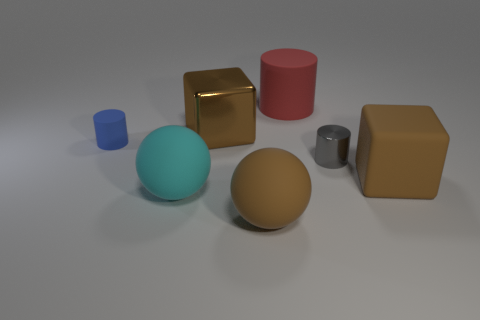What number of other things have the same material as the blue thing?
Your answer should be very brief. 4. There is a big metallic object; is its color the same as the matte thing that is to the right of the tiny gray metallic cylinder?
Give a very brief answer. Yes. What is the color of the tiny cylinder on the left side of the large brown matte thing that is left of the red cylinder?
Your response must be concise. Blue. There is a metal block that is the same size as the red rubber cylinder; what is its color?
Provide a succinct answer. Brown. Is there another cyan rubber thing that has the same shape as the large cyan object?
Ensure brevity in your answer.  No. What shape is the tiny gray shiny thing?
Make the answer very short. Cylinder. Are there more small blue cylinders to the right of the large cyan sphere than brown matte blocks left of the small blue object?
Provide a succinct answer. No. How many other things are there of the same size as the cyan ball?
Provide a short and direct response. 4. The large brown object that is both to the left of the small gray object and behind the big cyan object is made of what material?
Keep it short and to the point. Metal. There is a big brown object that is the same shape as the big cyan object; what is it made of?
Give a very brief answer. Rubber. 